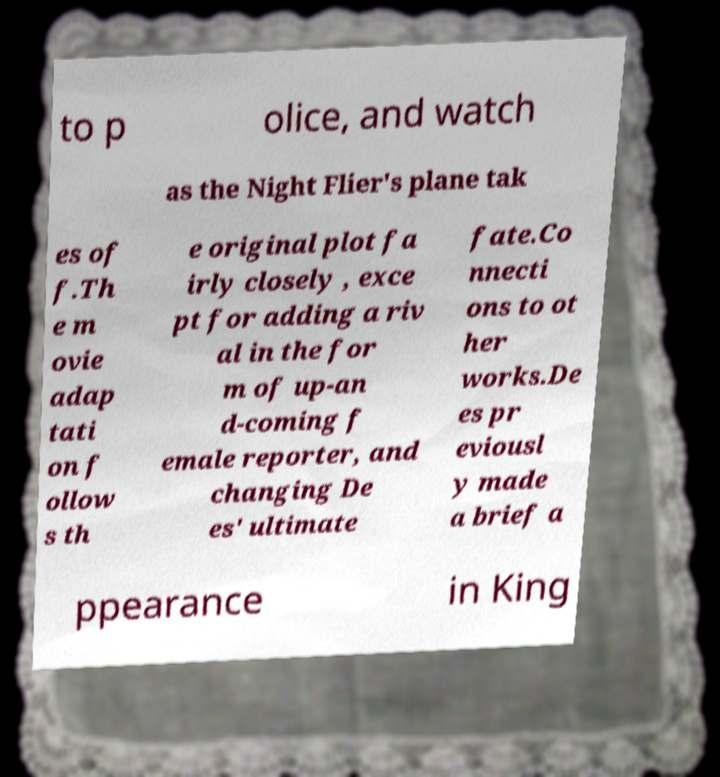I need the written content from this picture converted into text. Can you do that? to p olice, and watch as the Night Flier's plane tak es of f.Th e m ovie adap tati on f ollow s th e original plot fa irly closely , exce pt for adding a riv al in the for m of up-an d-coming f emale reporter, and changing De es' ultimate fate.Co nnecti ons to ot her works.De es pr eviousl y made a brief a ppearance in King 